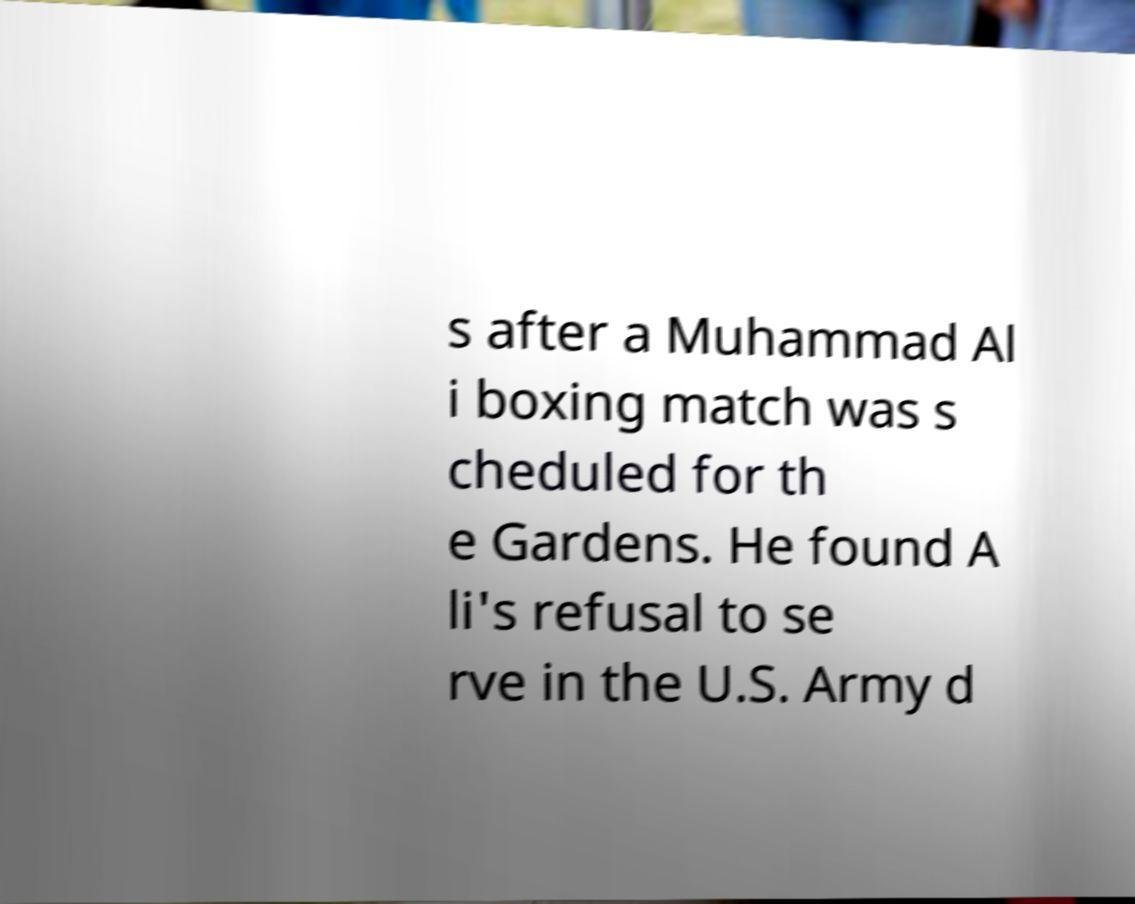Could you assist in decoding the text presented in this image and type it out clearly? s after a Muhammad Al i boxing match was s cheduled for th e Gardens. He found A li's refusal to se rve in the U.S. Army d 